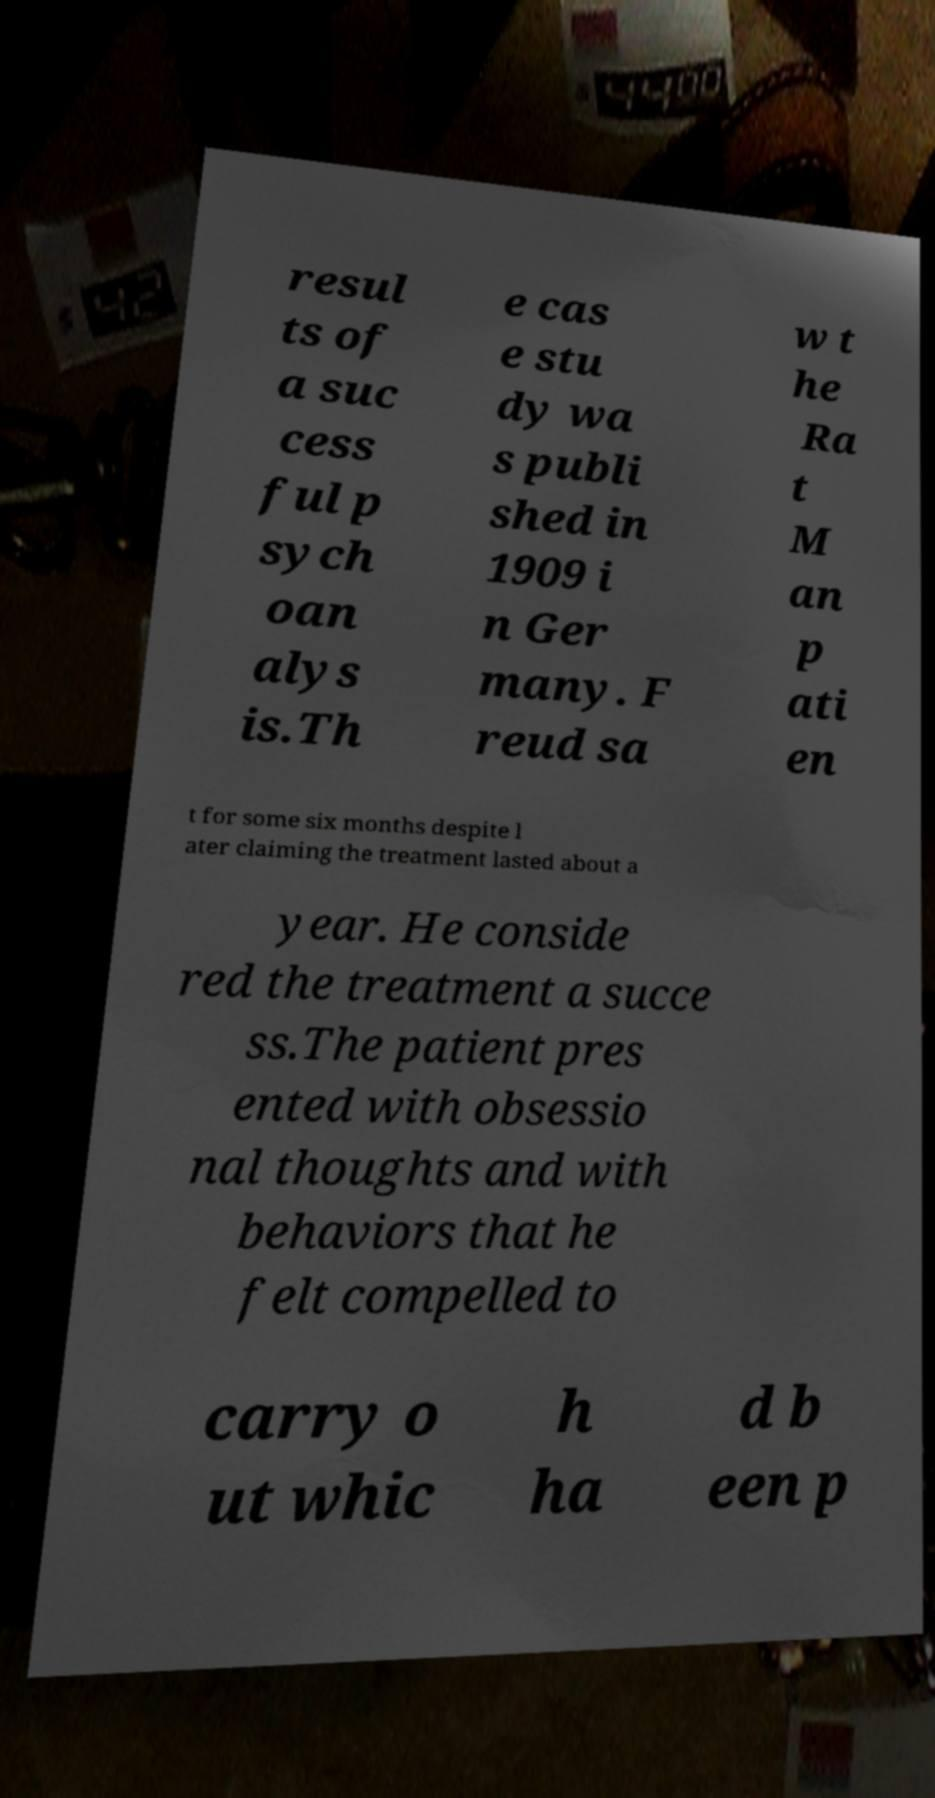Could you extract and type out the text from this image? resul ts of a suc cess ful p sych oan alys is.Th e cas e stu dy wa s publi shed in 1909 i n Ger many. F reud sa w t he Ra t M an p ati en t for some six months despite l ater claiming the treatment lasted about a year. He conside red the treatment a succe ss.The patient pres ented with obsessio nal thoughts and with behaviors that he felt compelled to carry o ut whic h ha d b een p 